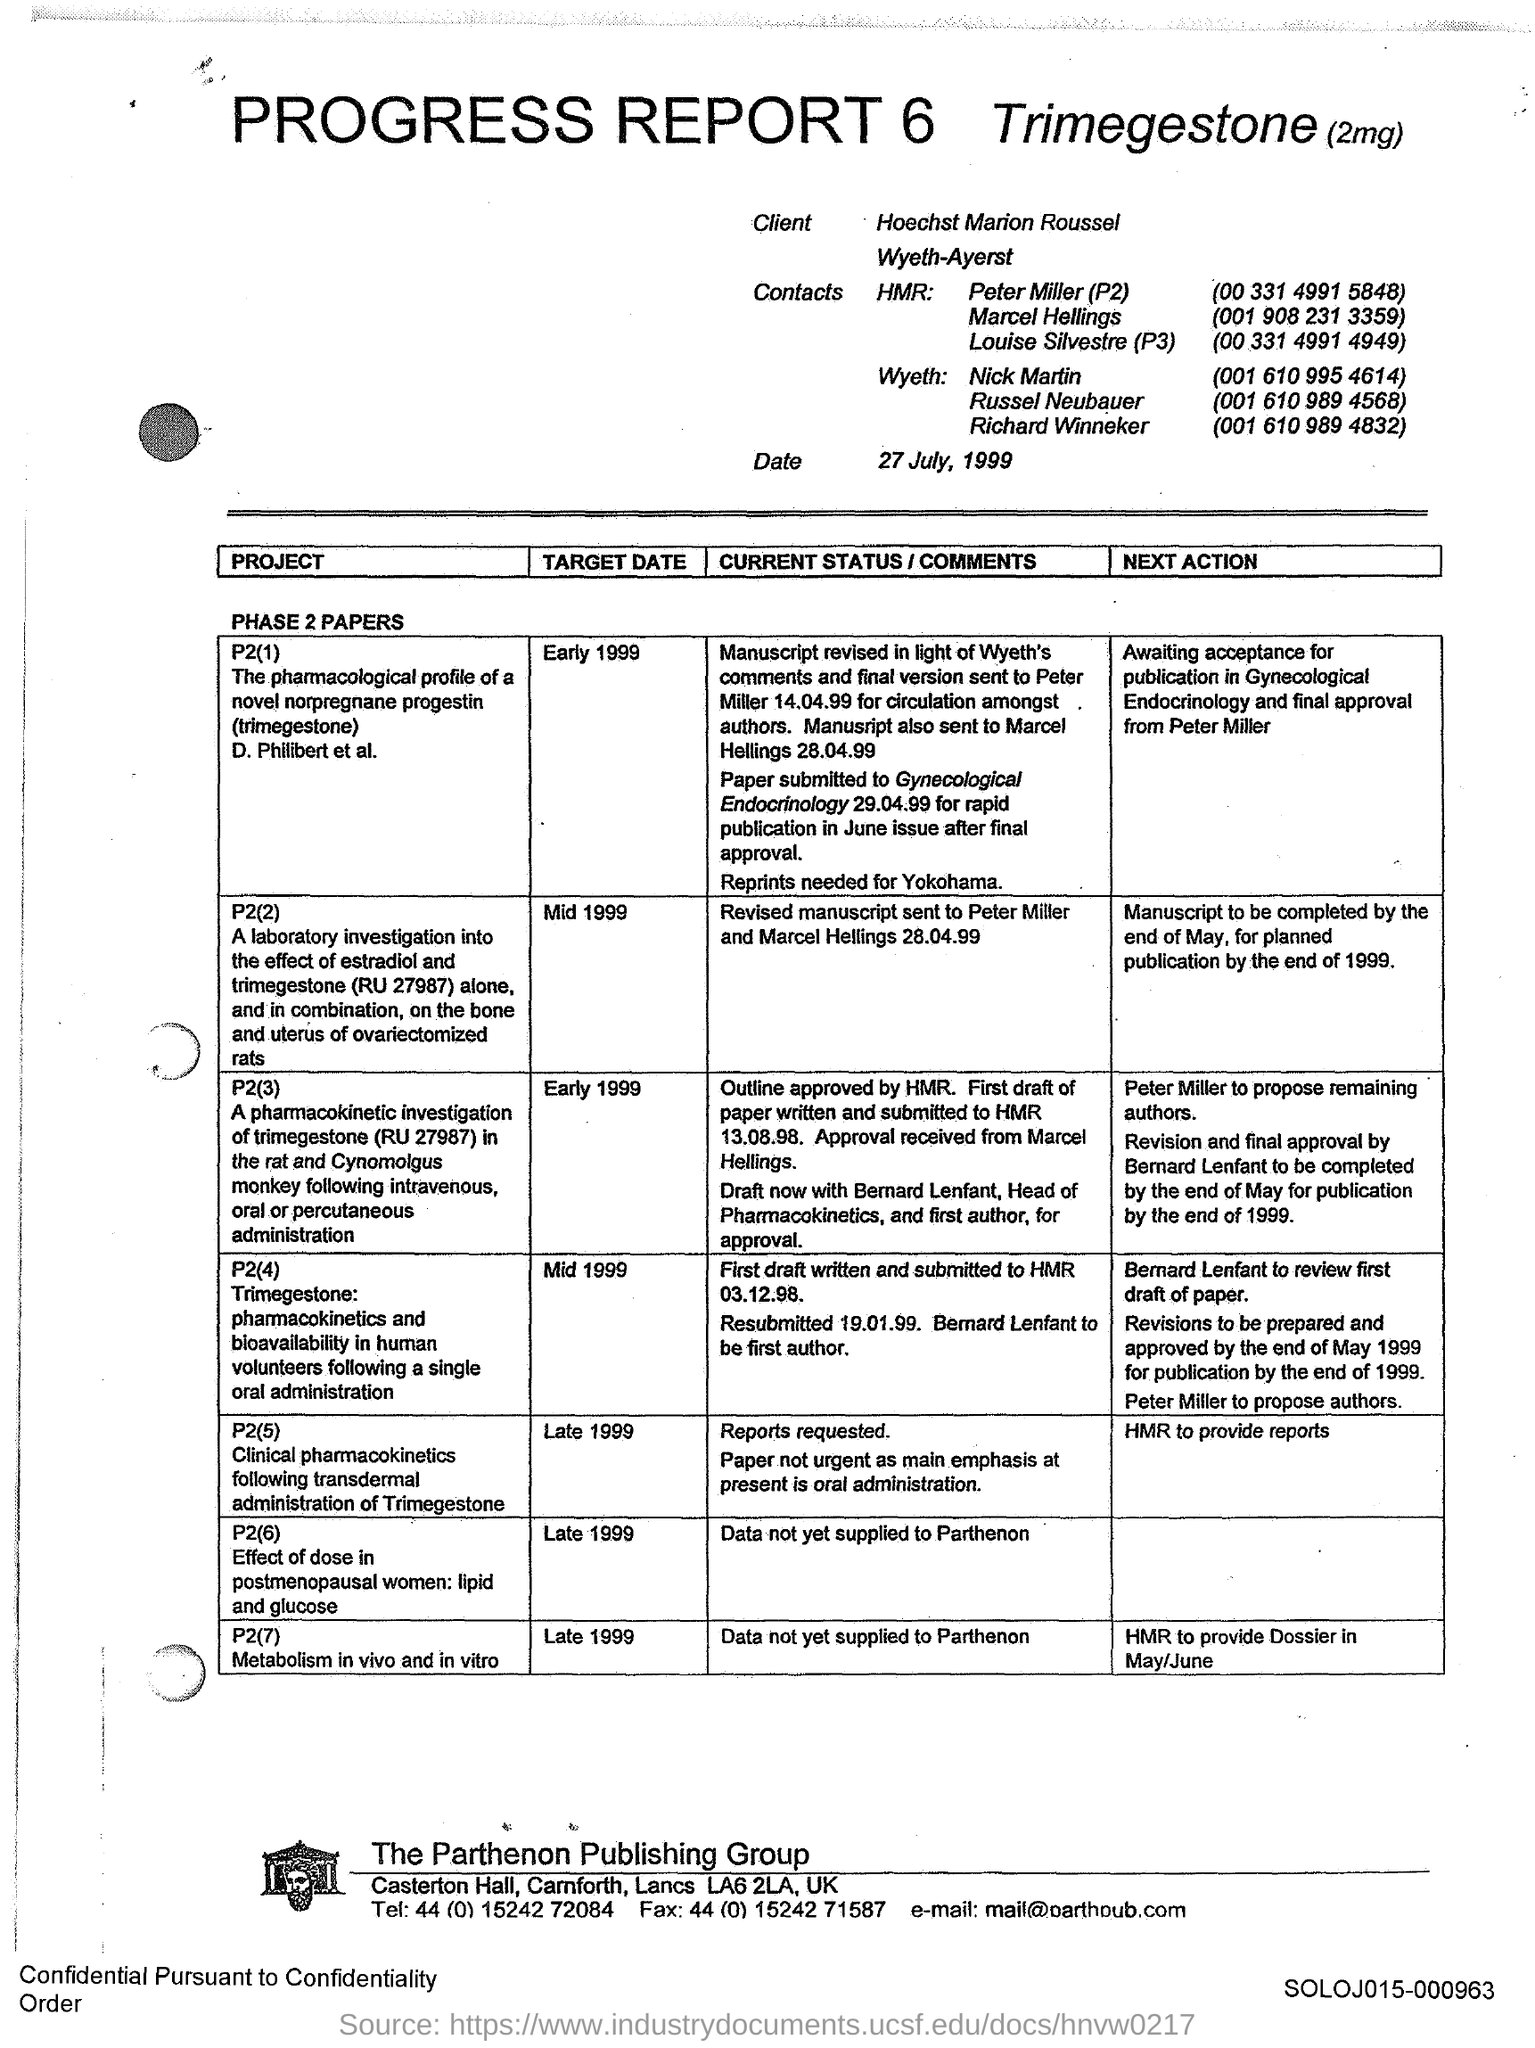Which report is this
Your answer should be compact. PROGRESS REPORT 6. 